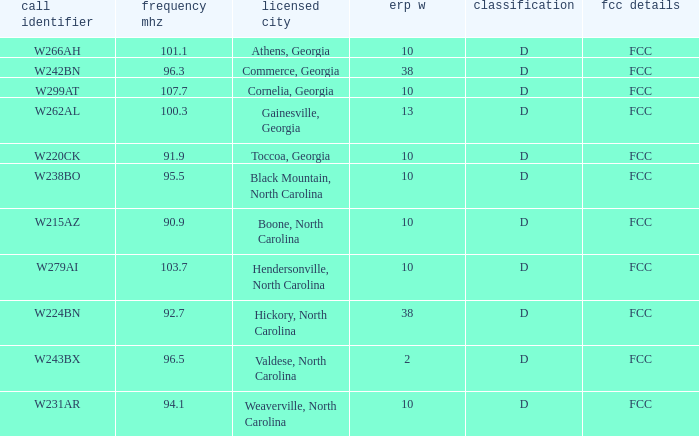What city has larger than 94.1 as a frequency? Athens, Georgia, Commerce, Georgia, Cornelia, Georgia, Gainesville, Georgia, Black Mountain, North Carolina, Hendersonville, North Carolina, Valdese, North Carolina. 